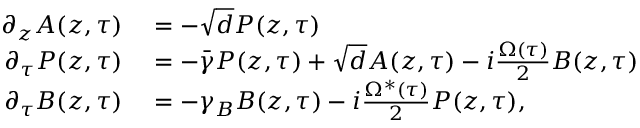Convert formula to latex. <formula><loc_0><loc_0><loc_500><loc_500>\begin{array} { r l } { \partial _ { z } A ( z , \tau ) } & = - \sqrt { d } P ( z , \tau ) } \\ { \partial _ { \tau } P ( z , \tau ) } & = - \bar { \gamma } P ( z , \tau ) + \sqrt { d } A ( z , \tau ) - i \frac { \Omega ( \tau ) } { 2 } B ( z , \tau ) } \\ { \partial _ { \tau } B ( z , \tau ) } & = - \gamma _ { B } B ( z , \tau ) - i \frac { \Omega ^ { * } ( \tau ) } { 2 } P ( z , \tau ) , } \end{array}</formula> 